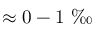Convert formula to latex. <formula><loc_0><loc_0><loc_500><loc_500>\approx 0 - 1 \text  perthousand</formula> 